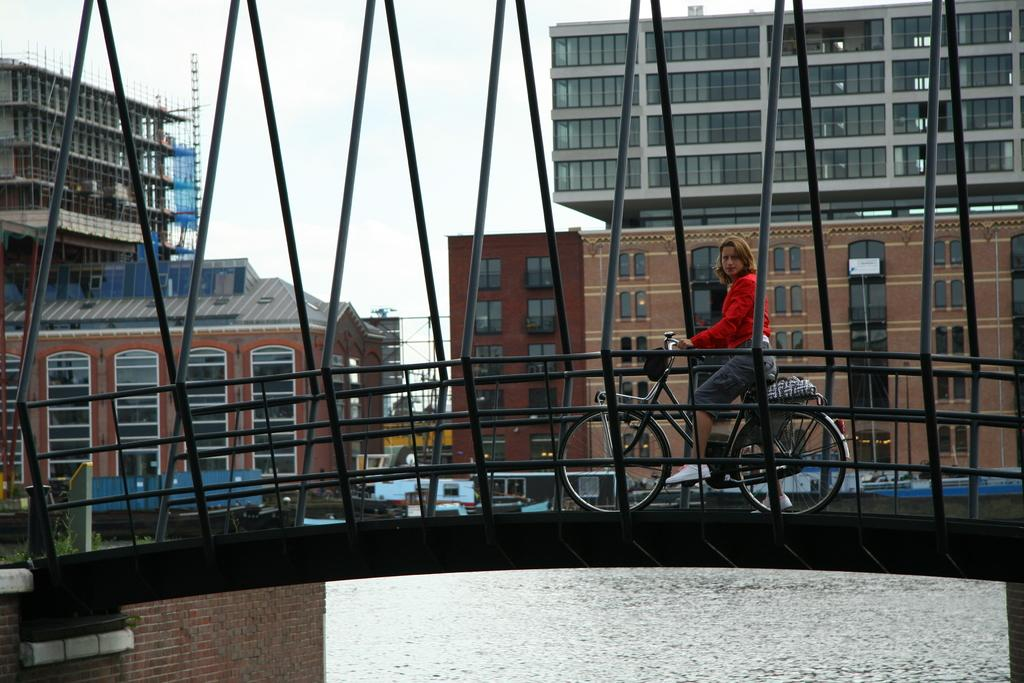Who is present in the image? There is a woman in the image. What is the woman doing in the image? The woman is with a cycle in the image. What can be seen in the background of the image? There are buildings and the sky visible in the background of the image. What type of cake is being shared between the woman and the heart in the image? There is no cake or heart present in the image; it features a woman with a cycle and a background of buildings and the sky. 